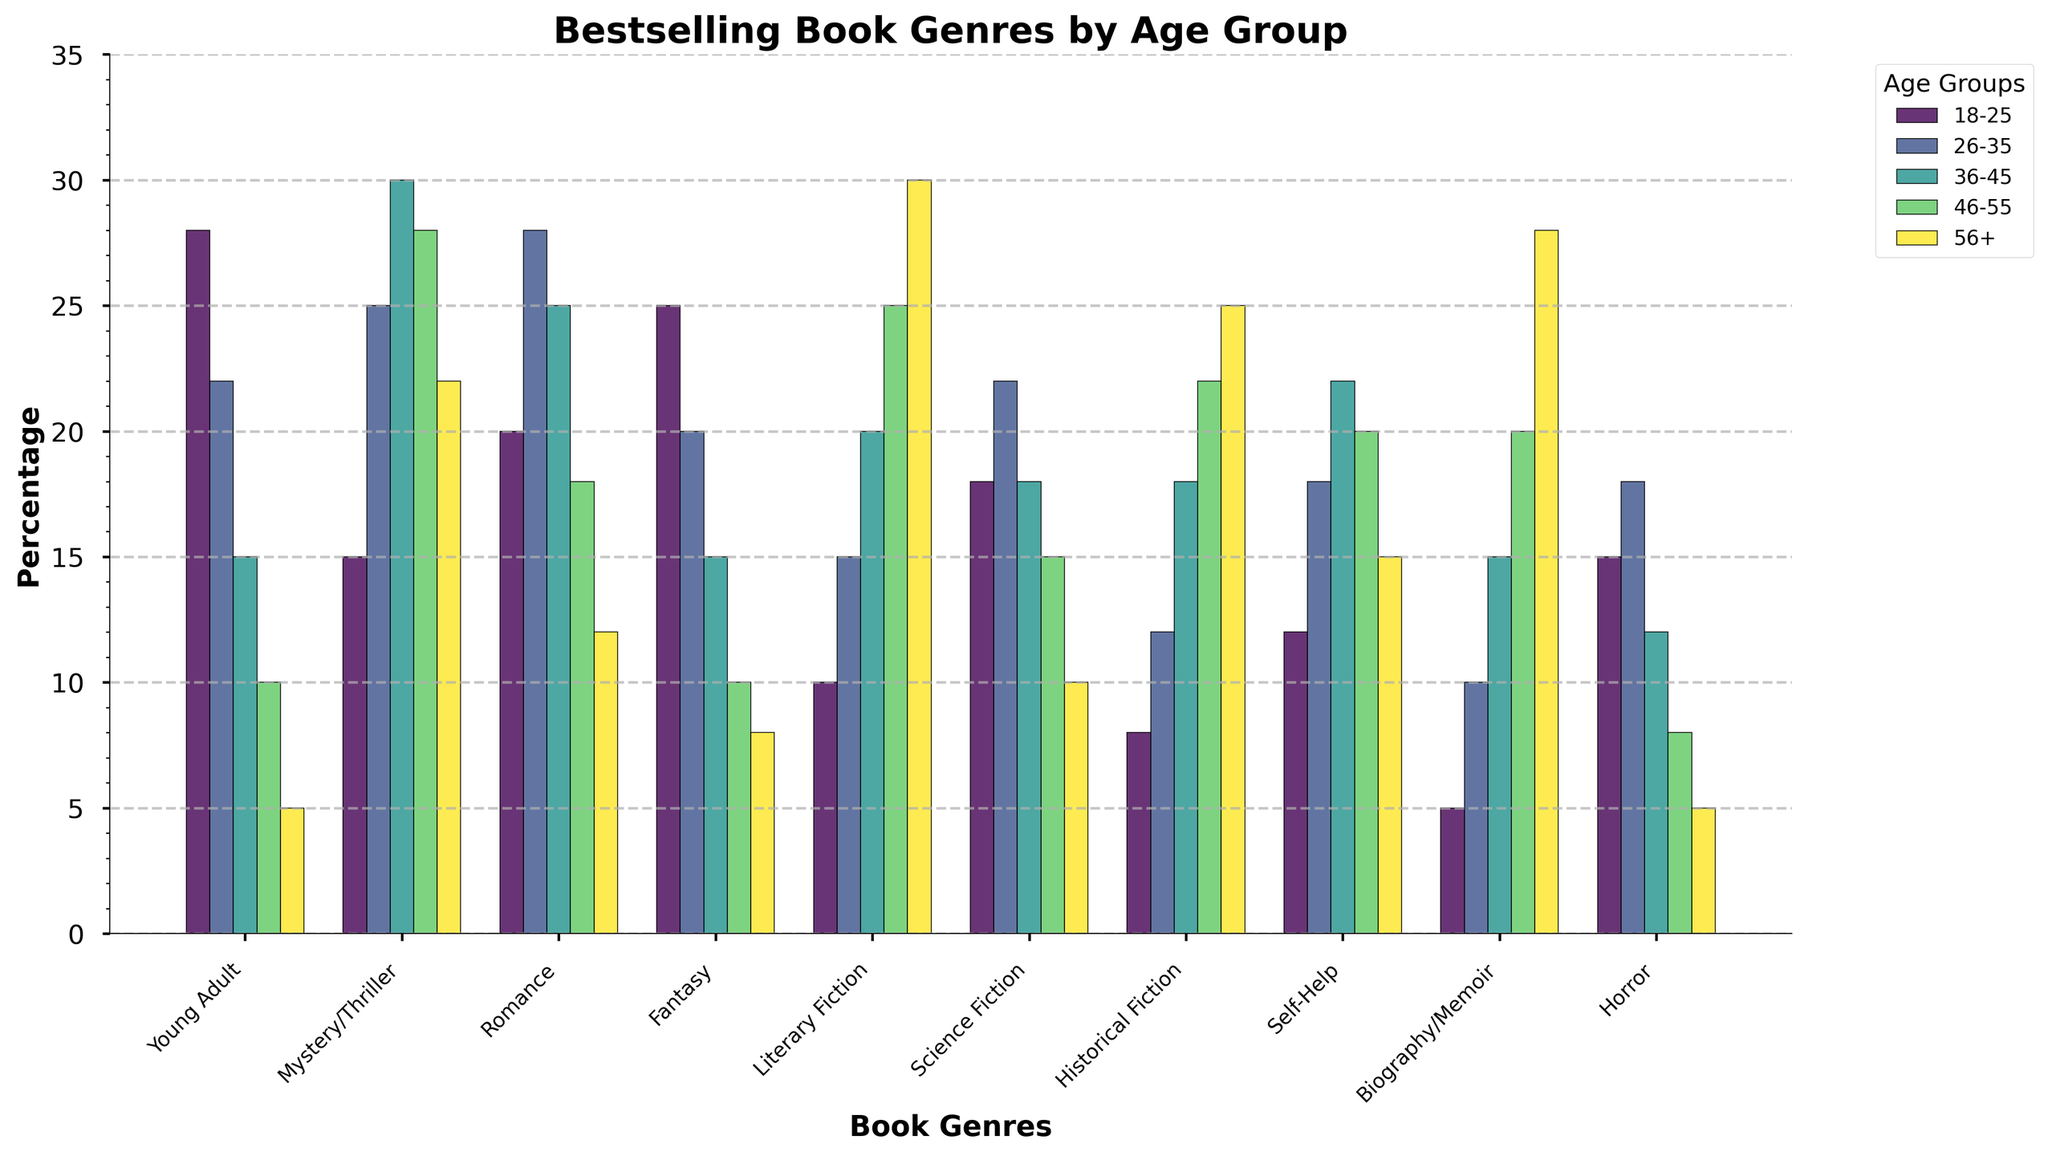Which age group has the highest percentage of Literary Fiction readers? Look at the bar heights for Literary Fiction. The tallest bar corresponds to the 56+ age group.
Answer: 56+ Which genre is the most favored among the 18-25 age group? Compare the heights of the bars for the 18-25 age group. The highest bar is for Young Adult.
Answer: Young Adult Are there any genres that have a consistent trend of increasing or decreasing popularity with age? Identify bars that either consistently increase or decrease from left to right across age groups. Literary Fiction and Historical Fiction show a consistent increasing trend, while Young Adult shows a decreasing trend.
Answer: Literary Fiction (increasing), Historical Fiction (increasing), Young Adult (decreasing) Which age group shows the most diverse interest across all genres? Look for the age group whose bars are the most evenly distributed across genres. The 26-35 age group's bars are more even compared to other groups.
Answer: 26-35 Which non-fiction genre is more popular among the 46-55 age group, Self-Help or Biography/Memoir? Compare the heights of the bars for Self-Help and Biography/Memoir within the 46-55 age group. The bar for Biography/Memoir is taller.
Answer: Biography/Memoir What is the difference in percentage points between the 18-25 and 56+ age groups for Mystery/Thriller? Subtract the value for the 56+ age group from the value for the 18-25 age group within the Mystery/Thriller genre. The values are 15 and 22 respectively, so 22 - 15 = 7 percentage points.
Answer: 7 What's the average percentage for Science Fiction readers across all age groups? Sum the percentages for Science Fiction across all age groups and divide by the number of groups. (18 + 22 + 18 + 15 + 10) / 5 = 16.6
Answer: 16.6 Which genre shows the least interest among the 36-45 age group? Find the genre with the shortest bar in the 36-45 age group. The shortest bar is for Horror.
Answer: Horror 